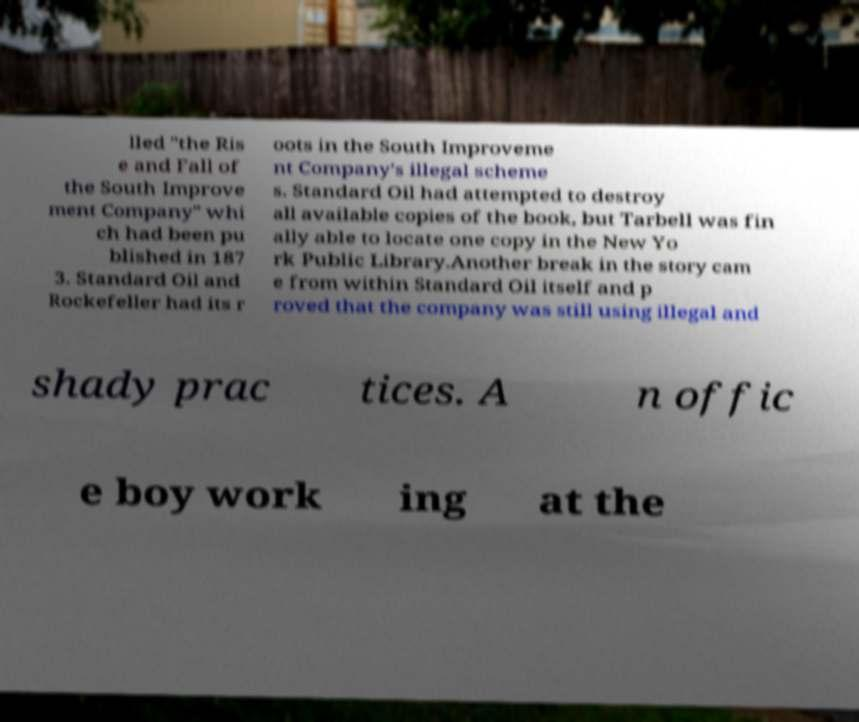Could you extract and type out the text from this image? lled "the Ris e and Fall of the South Improve ment Company" whi ch had been pu blished in 187 3. Standard Oil and Rockefeller had its r oots in the South Improveme nt Company's illegal scheme s. Standard Oil had attempted to destroy all available copies of the book, but Tarbell was fin ally able to locate one copy in the New Yo rk Public Library.Another break in the story cam e from within Standard Oil itself and p roved that the company was still using illegal and shady prac tices. A n offic e boy work ing at the 